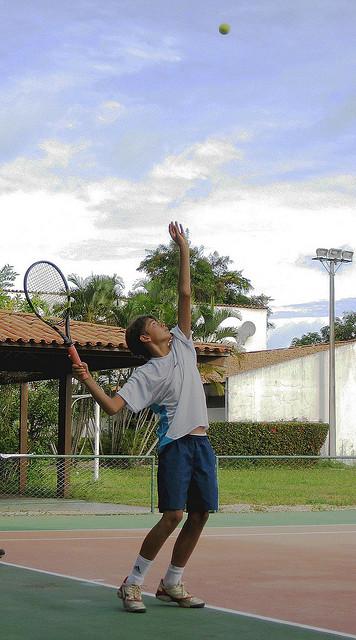What is the main color of the man's socks?
Short answer required. White. Is there a chain link fence in this scene?
Give a very brief answer. Yes. Is this person in the middle of serving?
Answer briefly. Yes. 